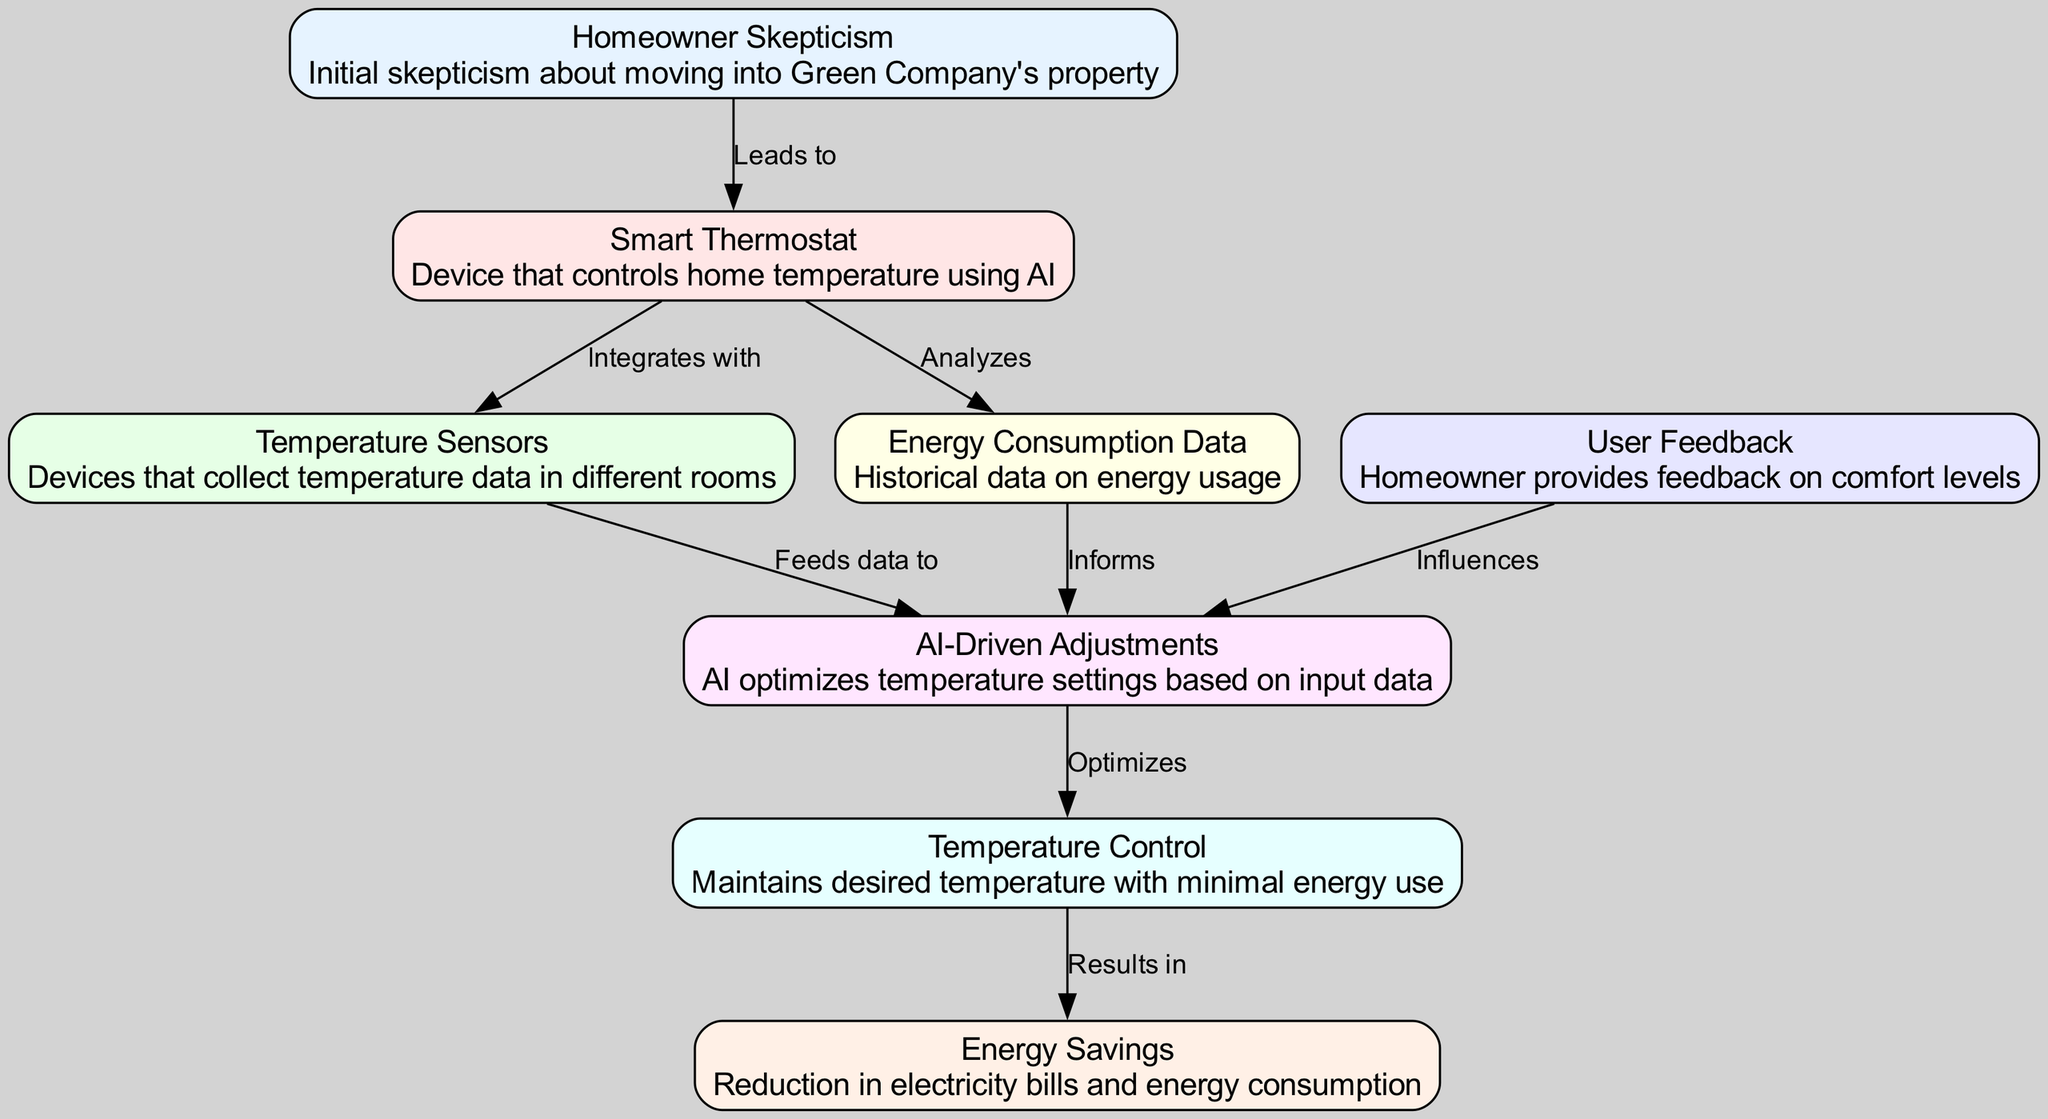What is the first node indicating a homeowner's attitude? The first node in the diagram is labeled "Homeowner Skepticism," which describes the initial feelings of the homeowner regarding moving into Green Company's property.
Answer: Homeowner Skepticism How many edges are present in the diagram? Counting the connections (or edges) between nodes, there are a total of 8 edges.
Answer: 8 What does the "Smart Thermostat" do in relation to temperature sensors? The "Smart Thermostat" node is connected to the "Temperature Sensors" node with the relation "Integrates with," indicating that it works with temperature sensors to collect data.
Answer: Integrates with Which node is influenced by user feedback? The arrow pointing from the "User Feedback" node to the "AI-Driven Adjustments" node indicates that user feedback impacts the AI's adjustments to the thermostat.
Answer: AI-Driven Adjustments What is the result of the AI adjustments according to the diagram? The flow of the diagram shows an edge from "AI-Driven Adjustments" to "Temperature Control," leading to the conclusion that AI adjustments optimize temperature control.
Answer: Optimizes What is the final outcome of the temperature control process? The connection from "Temperature Control" to "Energy Savings" indicates that effective temperature control results in energy savings.
Answer: Energy Savings How does the "Energy Consumption Data" contribute to the adjustments? The "Energy Consumption Data" node informs the "AI-Driven Adjustments," which means that historical energy usage data helps the AI in making informed adjustments.
Answer: Informs What two nodes directly connect to "AI-Driven Adjustments"? The "Temperature Sensors" and "Energy Data" nodes connect to "AI-Driven Adjustments" based on their respective edges, meaning they both supply crucial information to the AI.
Answer: Temperature Sensors, Energy Data 